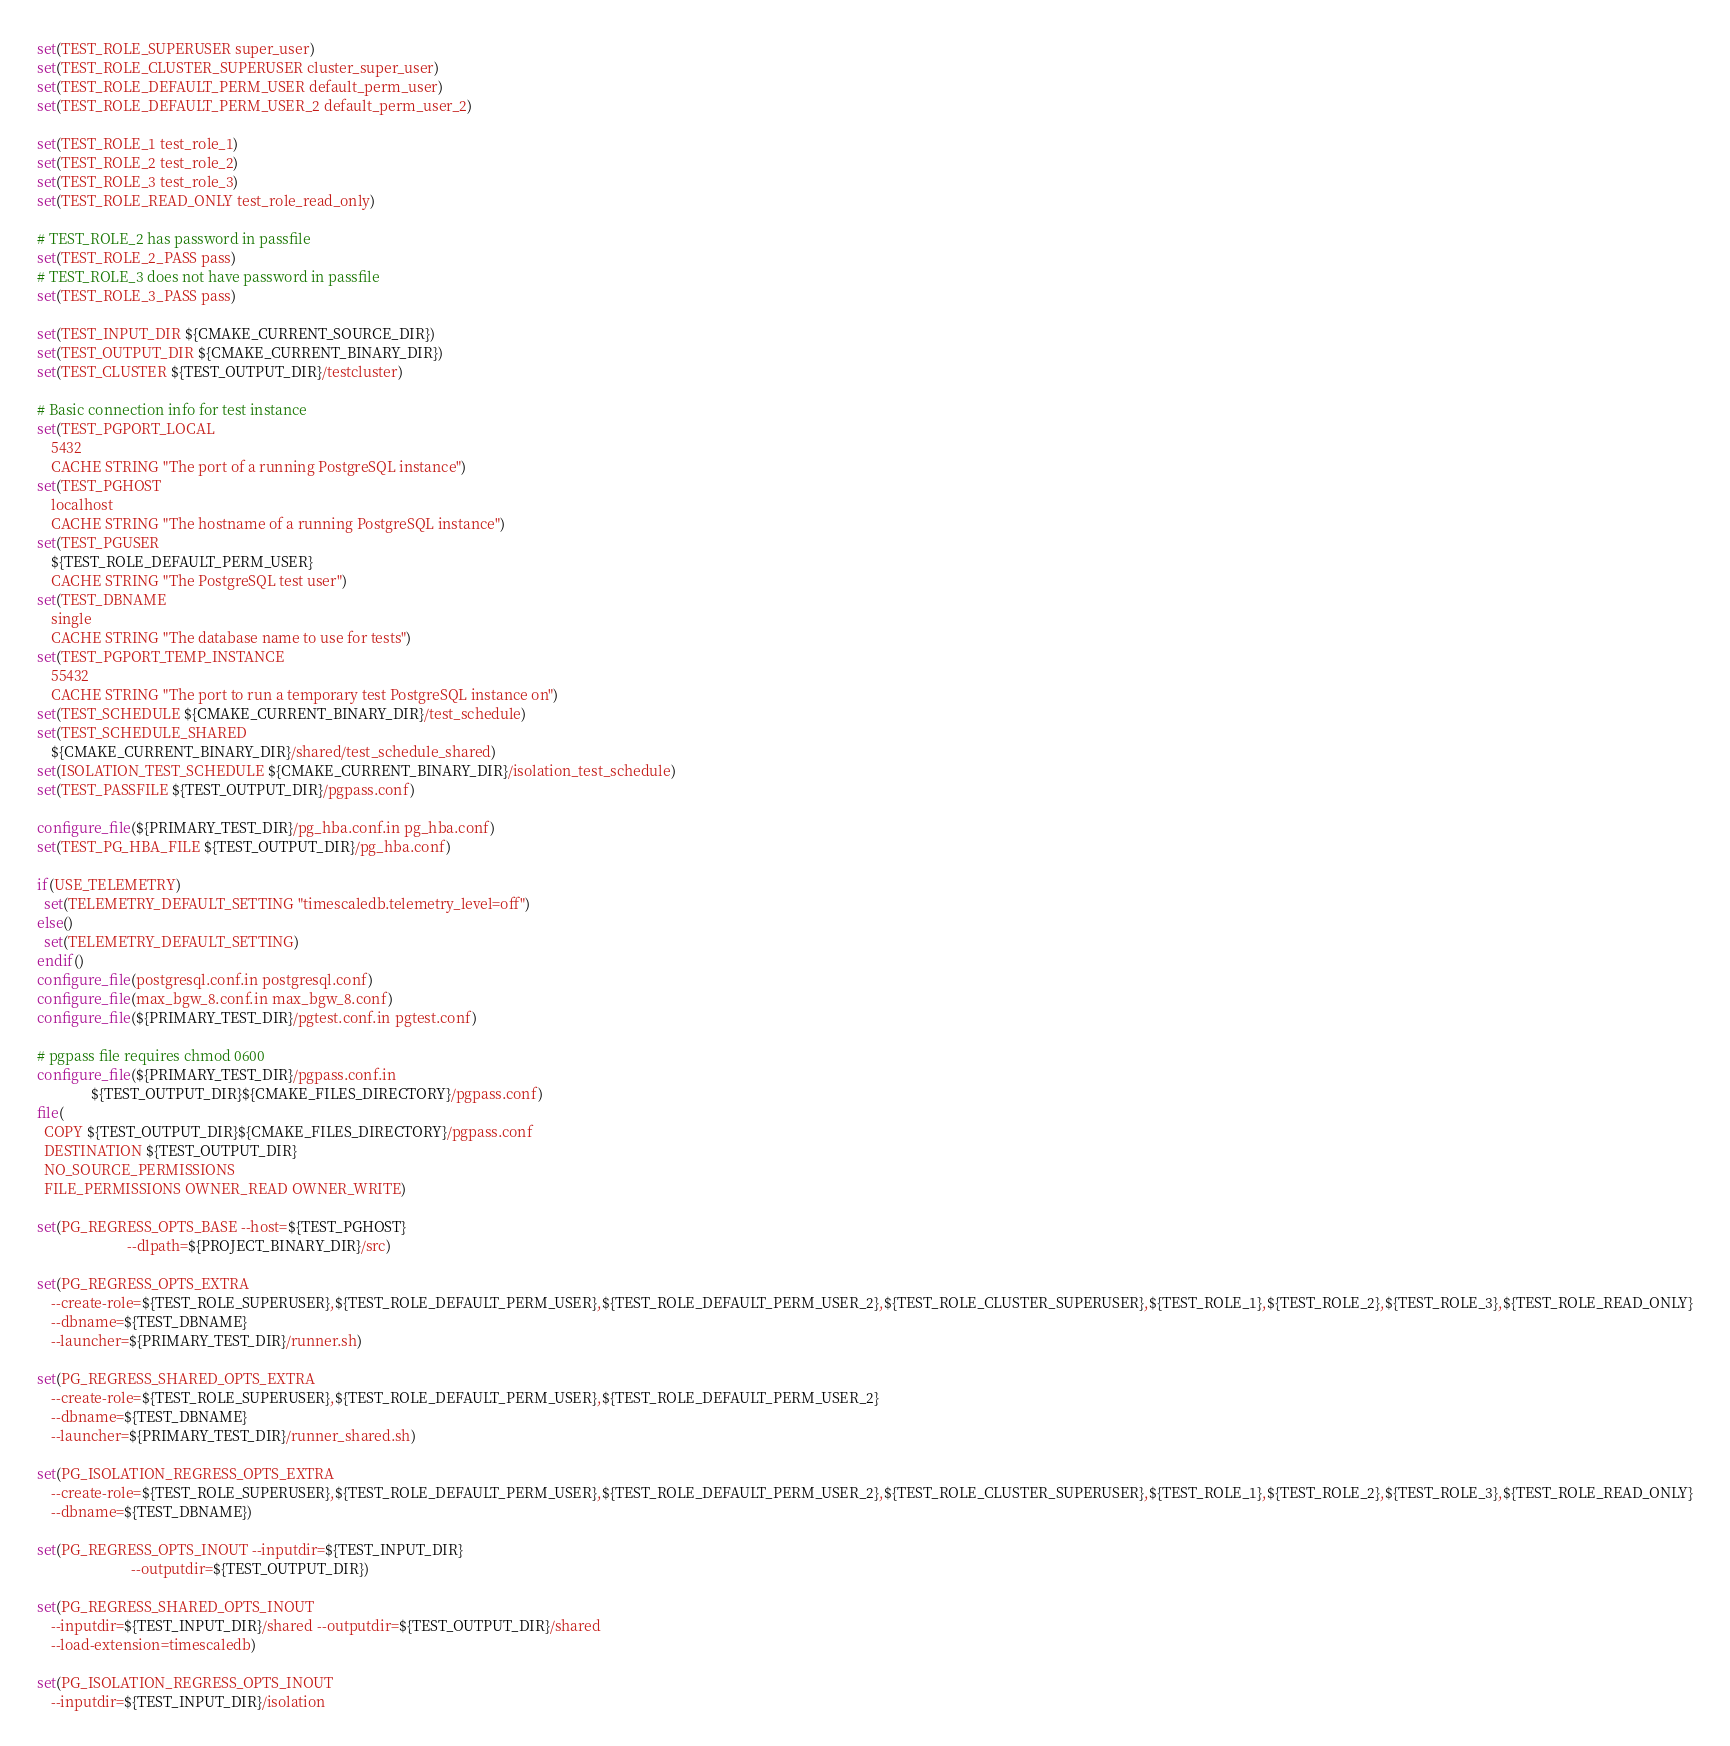Convert code to text. <code><loc_0><loc_0><loc_500><loc_500><_CMake_>set(TEST_ROLE_SUPERUSER super_user)
set(TEST_ROLE_CLUSTER_SUPERUSER cluster_super_user)
set(TEST_ROLE_DEFAULT_PERM_USER default_perm_user)
set(TEST_ROLE_DEFAULT_PERM_USER_2 default_perm_user_2)

set(TEST_ROLE_1 test_role_1)
set(TEST_ROLE_2 test_role_2)
set(TEST_ROLE_3 test_role_3)
set(TEST_ROLE_READ_ONLY test_role_read_only)

# TEST_ROLE_2 has password in passfile
set(TEST_ROLE_2_PASS pass)
# TEST_ROLE_3 does not have password in passfile
set(TEST_ROLE_3_PASS pass)

set(TEST_INPUT_DIR ${CMAKE_CURRENT_SOURCE_DIR})
set(TEST_OUTPUT_DIR ${CMAKE_CURRENT_BINARY_DIR})
set(TEST_CLUSTER ${TEST_OUTPUT_DIR}/testcluster)

# Basic connection info for test instance
set(TEST_PGPORT_LOCAL
    5432
    CACHE STRING "The port of a running PostgreSQL instance")
set(TEST_PGHOST
    localhost
    CACHE STRING "The hostname of a running PostgreSQL instance")
set(TEST_PGUSER
    ${TEST_ROLE_DEFAULT_PERM_USER}
    CACHE STRING "The PostgreSQL test user")
set(TEST_DBNAME
    single
    CACHE STRING "The database name to use for tests")
set(TEST_PGPORT_TEMP_INSTANCE
    55432
    CACHE STRING "The port to run a temporary test PostgreSQL instance on")
set(TEST_SCHEDULE ${CMAKE_CURRENT_BINARY_DIR}/test_schedule)
set(TEST_SCHEDULE_SHARED
    ${CMAKE_CURRENT_BINARY_DIR}/shared/test_schedule_shared)
set(ISOLATION_TEST_SCHEDULE ${CMAKE_CURRENT_BINARY_DIR}/isolation_test_schedule)
set(TEST_PASSFILE ${TEST_OUTPUT_DIR}/pgpass.conf)

configure_file(${PRIMARY_TEST_DIR}/pg_hba.conf.in pg_hba.conf)
set(TEST_PG_HBA_FILE ${TEST_OUTPUT_DIR}/pg_hba.conf)

if(USE_TELEMETRY)
  set(TELEMETRY_DEFAULT_SETTING "timescaledb.telemetry_level=off")
else()
  set(TELEMETRY_DEFAULT_SETTING)
endif()
configure_file(postgresql.conf.in postgresql.conf)
configure_file(max_bgw_8.conf.in max_bgw_8.conf)
configure_file(${PRIMARY_TEST_DIR}/pgtest.conf.in pgtest.conf)

# pgpass file requires chmod 0600
configure_file(${PRIMARY_TEST_DIR}/pgpass.conf.in
               ${TEST_OUTPUT_DIR}${CMAKE_FILES_DIRECTORY}/pgpass.conf)
file(
  COPY ${TEST_OUTPUT_DIR}${CMAKE_FILES_DIRECTORY}/pgpass.conf
  DESTINATION ${TEST_OUTPUT_DIR}
  NO_SOURCE_PERMISSIONS
  FILE_PERMISSIONS OWNER_READ OWNER_WRITE)

set(PG_REGRESS_OPTS_BASE --host=${TEST_PGHOST}
                         --dlpath=${PROJECT_BINARY_DIR}/src)

set(PG_REGRESS_OPTS_EXTRA
    --create-role=${TEST_ROLE_SUPERUSER},${TEST_ROLE_DEFAULT_PERM_USER},${TEST_ROLE_DEFAULT_PERM_USER_2},${TEST_ROLE_CLUSTER_SUPERUSER},${TEST_ROLE_1},${TEST_ROLE_2},${TEST_ROLE_3},${TEST_ROLE_READ_ONLY}
    --dbname=${TEST_DBNAME}
    --launcher=${PRIMARY_TEST_DIR}/runner.sh)

set(PG_REGRESS_SHARED_OPTS_EXTRA
    --create-role=${TEST_ROLE_SUPERUSER},${TEST_ROLE_DEFAULT_PERM_USER},${TEST_ROLE_DEFAULT_PERM_USER_2}
    --dbname=${TEST_DBNAME}
    --launcher=${PRIMARY_TEST_DIR}/runner_shared.sh)

set(PG_ISOLATION_REGRESS_OPTS_EXTRA
    --create-role=${TEST_ROLE_SUPERUSER},${TEST_ROLE_DEFAULT_PERM_USER},${TEST_ROLE_DEFAULT_PERM_USER_2},${TEST_ROLE_CLUSTER_SUPERUSER},${TEST_ROLE_1},${TEST_ROLE_2},${TEST_ROLE_3},${TEST_ROLE_READ_ONLY}
    --dbname=${TEST_DBNAME})

set(PG_REGRESS_OPTS_INOUT --inputdir=${TEST_INPUT_DIR}
                          --outputdir=${TEST_OUTPUT_DIR})

set(PG_REGRESS_SHARED_OPTS_INOUT
    --inputdir=${TEST_INPUT_DIR}/shared --outputdir=${TEST_OUTPUT_DIR}/shared
    --load-extension=timescaledb)

set(PG_ISOLATION_REGRESS_OPTS_INOUT
    --inputdir=${TEST_INPUT_DIR}/isolation</code> 